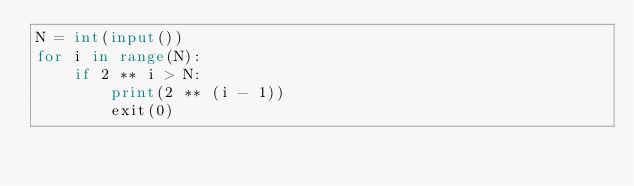<code> <loc_0><loc_0><loc_500><loc_500><_Python_>N = int(input())
for i in range(N):
    if 2 ** i > N:
        print(2 ** (i - 1))
        exit(0)
</code> 